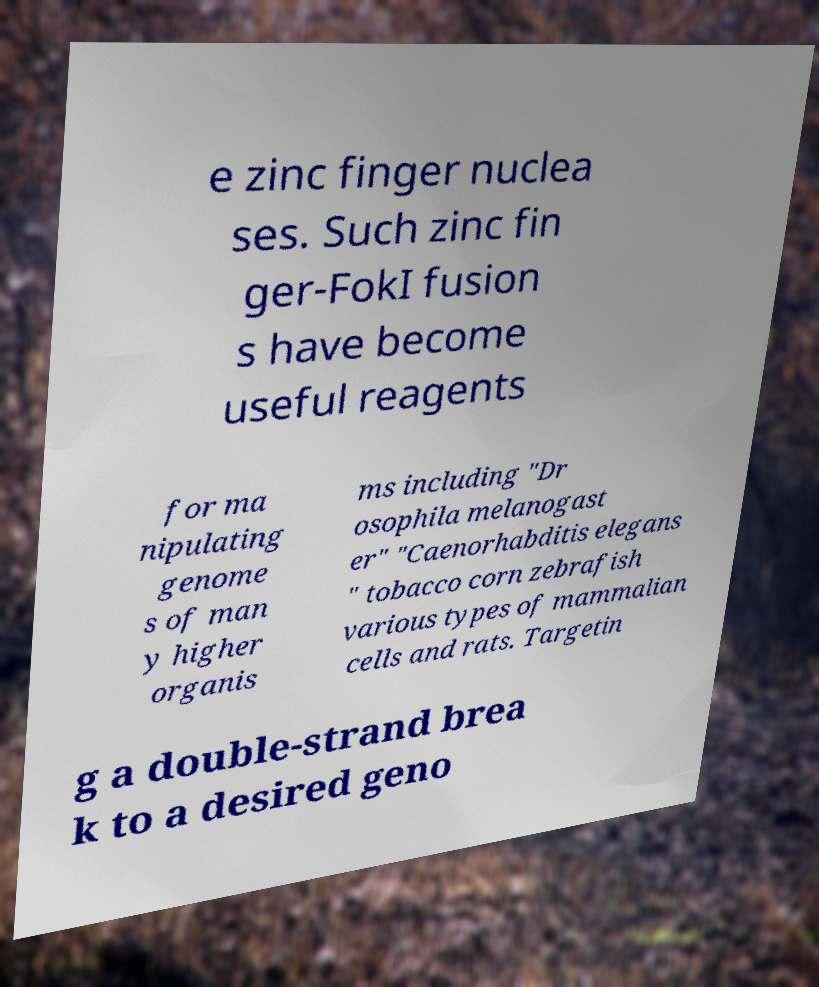What messages or text are displayed in this image? I need them in a readable, typed format. e zinc finger nuclea ses. Such zinc fin ger-FokI fusion s have become useful reagents for ma nipulating genome s of man y higher organis ms including "Dr osophila melanogast er" "Caenorhabditis elegans " tobacco corn zebrafish various types of mammalian cells and rats. Targetin g a double-strand brea k to a desired geno 